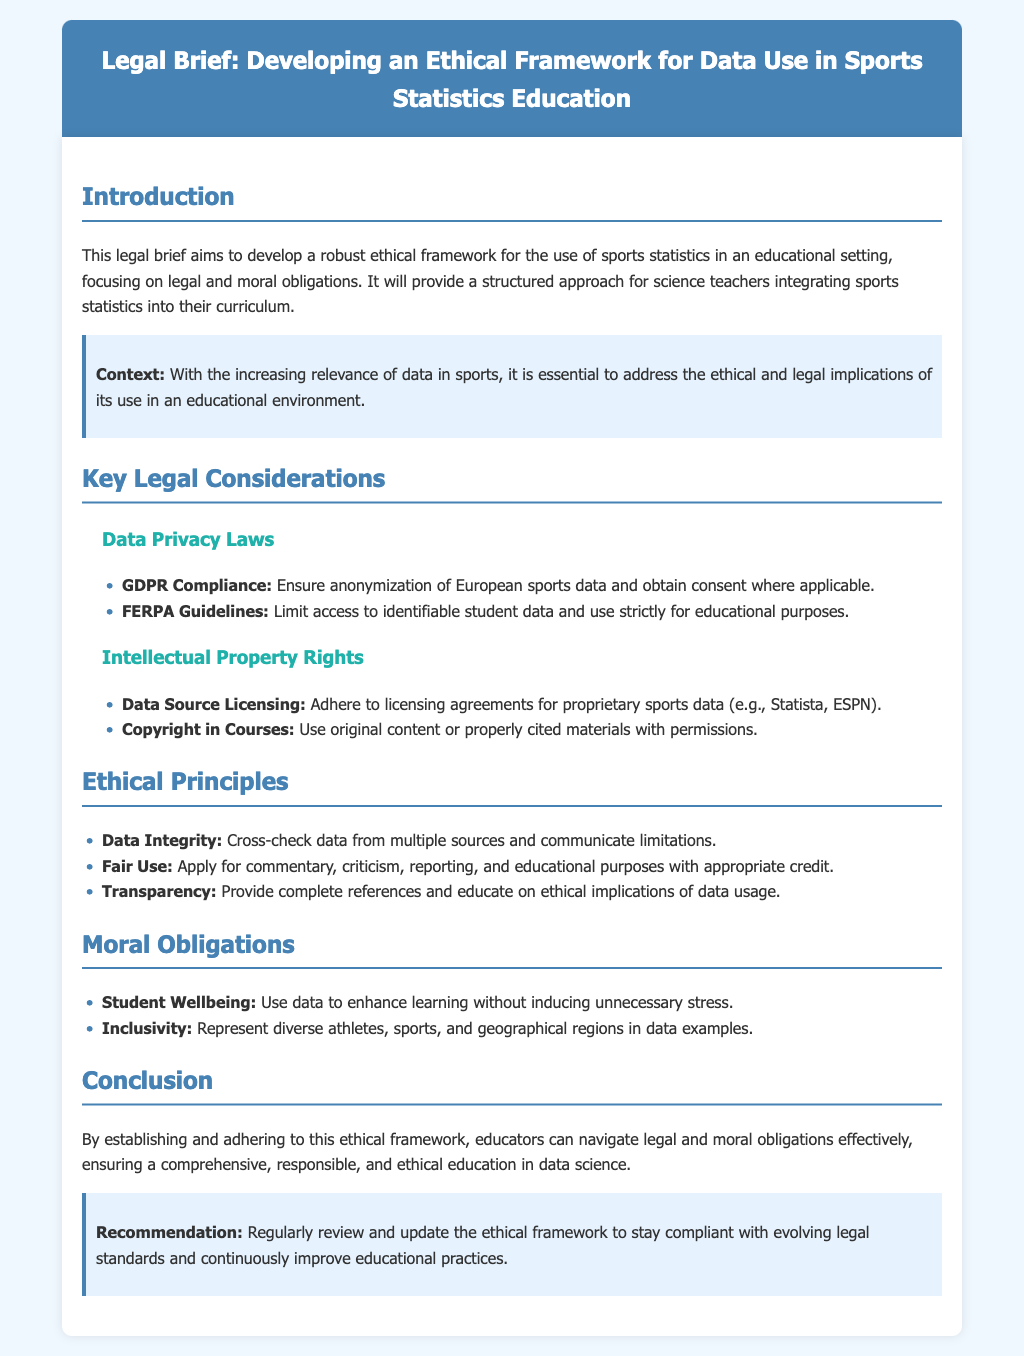What is the title of the document? The title provides a clear identification of the document’s purpose, which is "Legal Brief: Developing an Ethical Framework for Data Use in Sports Statistics Education".
Answer: Legal Brief: Developing an Ethical Framework for Data Use in Sports Statistics Education What are the two key legal considerations mentioned? The document lists specific legal components under "Key Legal Considerations", which are "Data Privacy Laws" and "Intellectual Property Rights".
Answer: Data Privacy Laws, Intellectual Property Rights What is one ethical principle outlined in the document? The document enumerates several ethical principles, one of which is "Data Integrity".
Answer: Data Integrity What does GDPR stand for? The acronym is mentioned in the context of data privacy laws in the document, referring to a specific regulation.
Answer: General Data Protection Regulation What is a moral obligation highlighted in the document? The document specifies moral obligations, such as "Student Wellbeing".
Answer: Student Wellbeing What is the recommendation given in the conclusion? The conclusion contains a suggestion for ongoing action related to the ethical framework, which is to "Regularly review and update the ethical framework".
Answer: Regularly review and update the ethical framework What color is the header of the document? The document describes the styling of its header, indicating that the background color is "blue".
Answer: blue What does the "Highlight" section address about context? The highlighted context recognizes the importance of addressing ethical and legal implications in education regarding sports data.
Answer: Ethical and legal implications of its use in an educational environment 